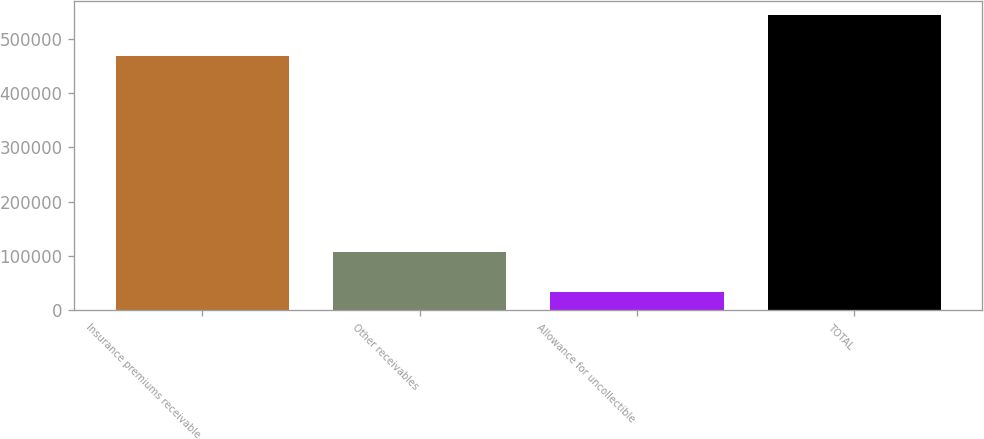<chart> <loc_0><loc_0><loc_500><loc_500><bar_chart><fcel>Insurance premiums receivable<fcel>Other receivables<fcel>Allowance for uncollectible<fcel>TOTAL<nl><fcel>468334<fcel>107721<fcel>33128<fcel>542927<nl></chart> 